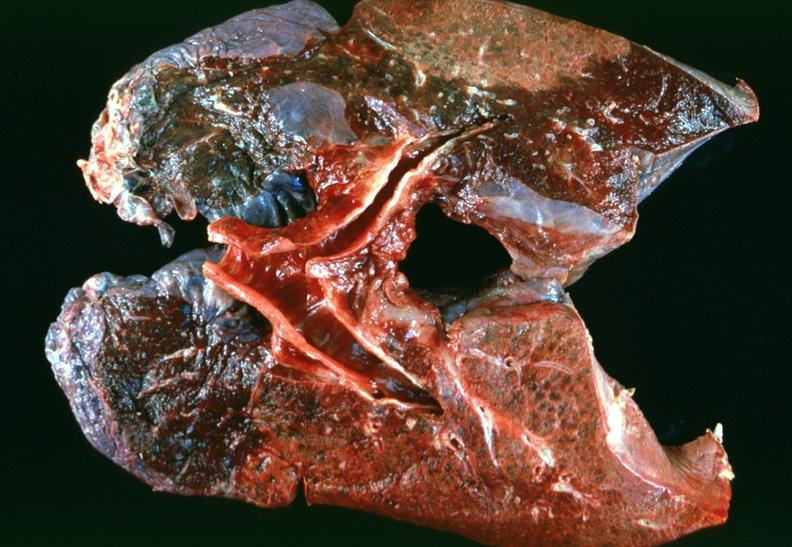s respiratory present?
Answer the question using a single word or phrase. Yes 